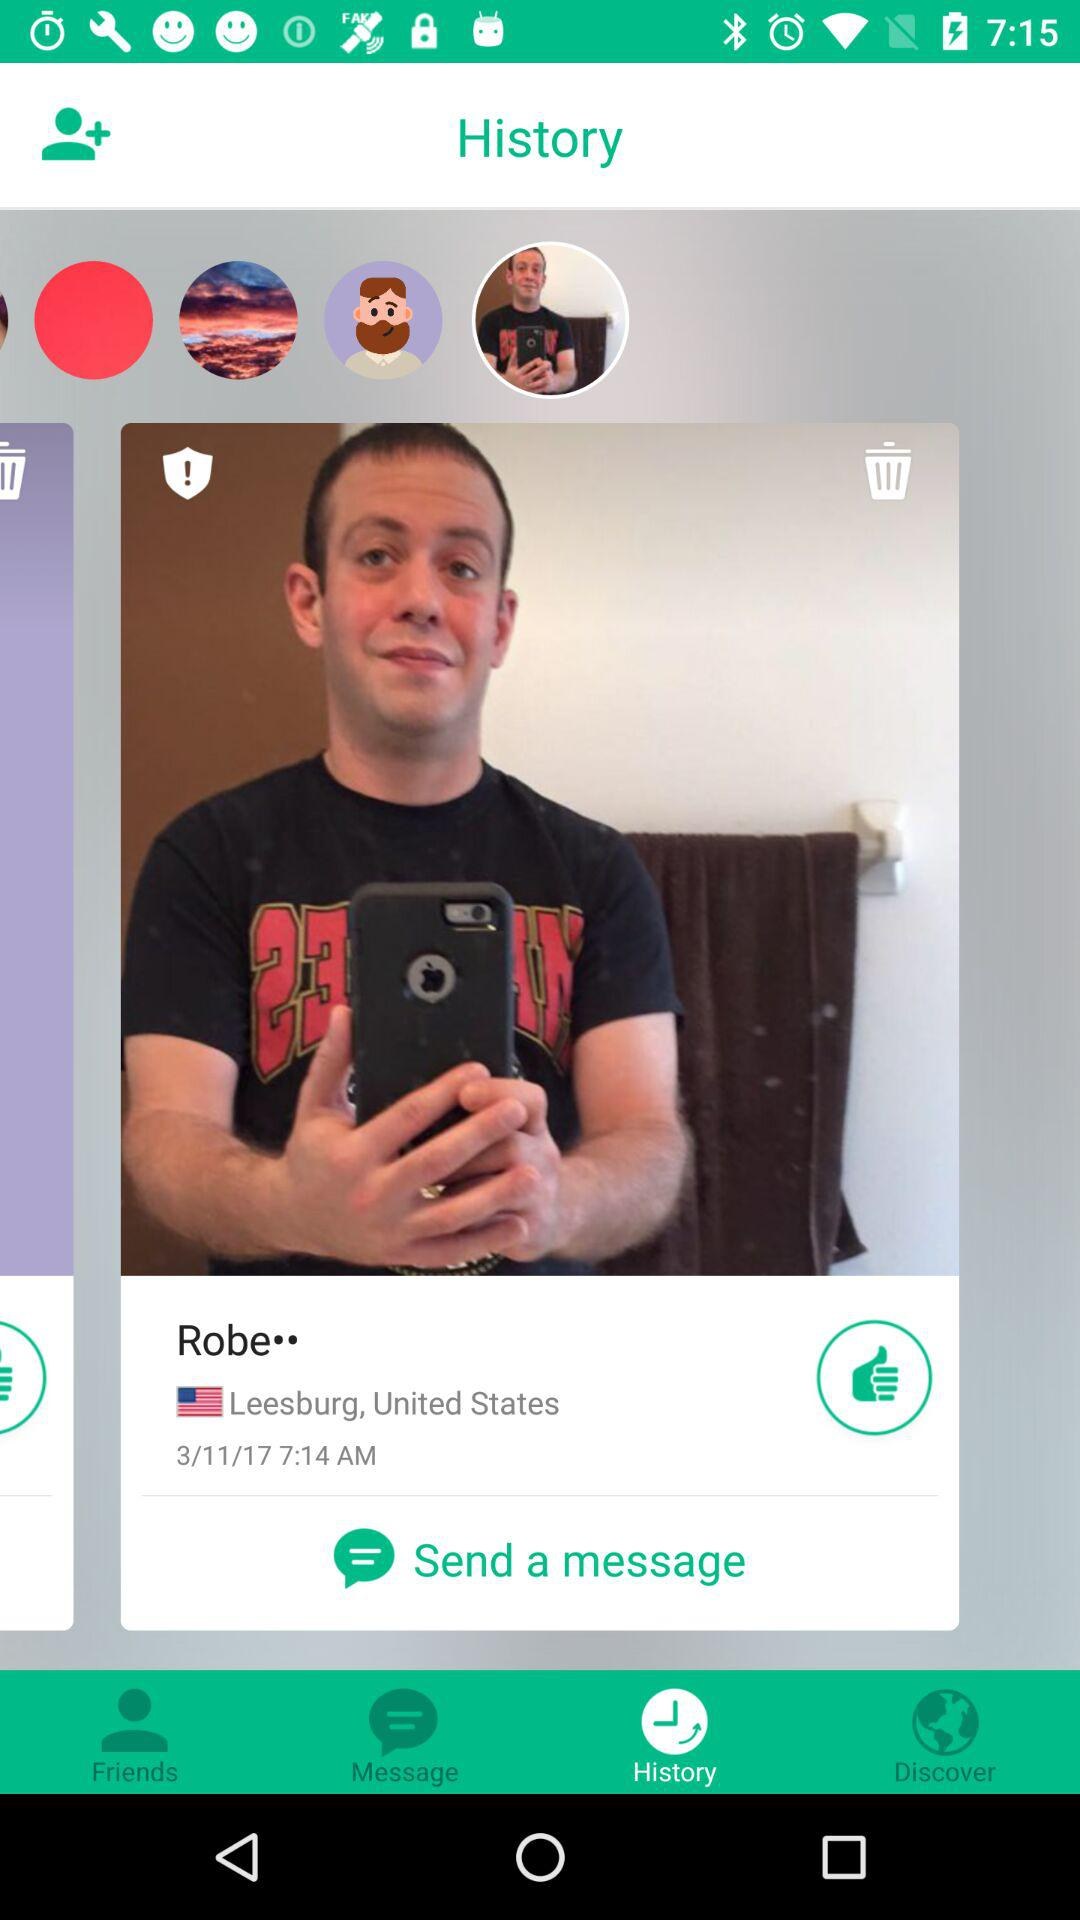Which users are listed as friends?
When the provided information is insufficient, respond with <no answer>. <no answer> 